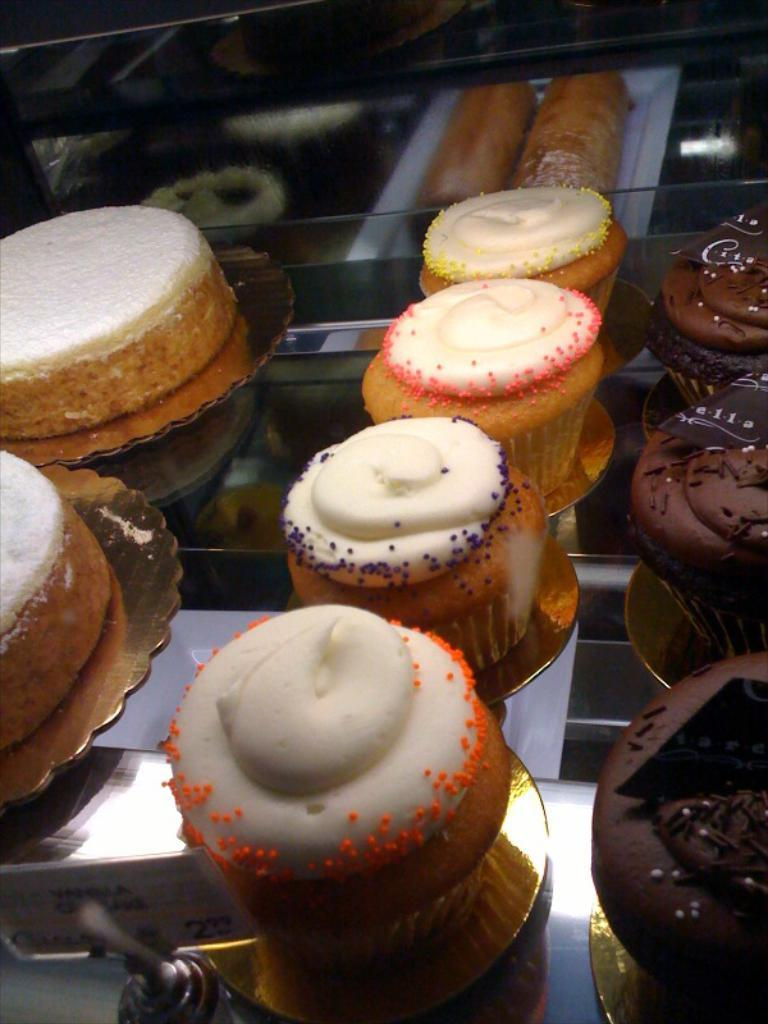What type of food is visible in the image? There are cupcakes in the image. Where are the cupcakes located? The cupcakes are placed on a glass table. How many geese are swimming around the island in the image? There is no island or geese present in the image; it features cupcakes on a glass table. 